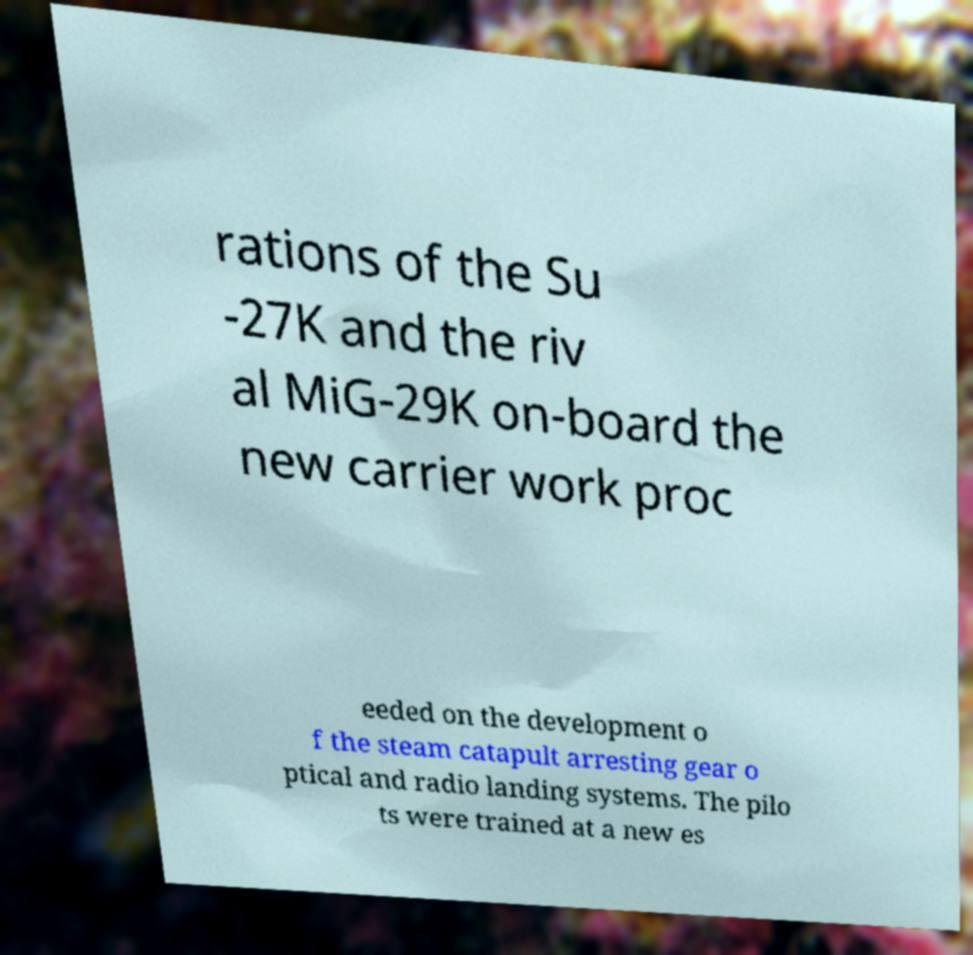There's text embedded in this image that I need extracted. Can you transcribe it verbatim? rations of the Su -27K and the riv al MiG-29K on-board the new carrier work proc eeded on the development o f the steam catapult arresting gear o ptical and radio landing systems. The pilo ts were trained at a new es 